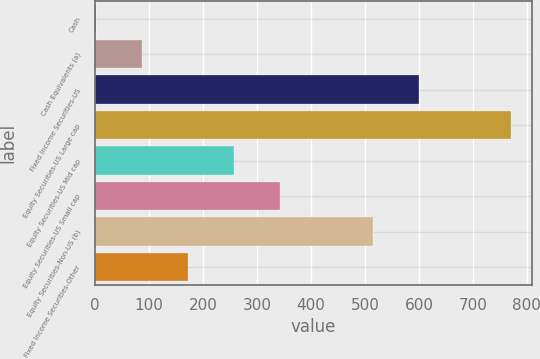<chart> <loc_0><loc_0><loc_500><loc_500><bar_chart><fcel>Cash<fcel>Cash Equivalents (a)<fcel>Fixed Income Securities-US<fcel>Equity Securities-US Large cap<fcel>Equity Securities-US Mid cap<fcel>Equity Securities-US Small cap<fcel>Equity Securities-Non-US (b)<fcel>Fixed Income Securities-Other<nl><fcel>2<fcel>87.4<fcel>599.8<fcel>770.6<fcel>258.2<fcel>343.6<fcel>514.4<fcel>172.8<nl></chart> 